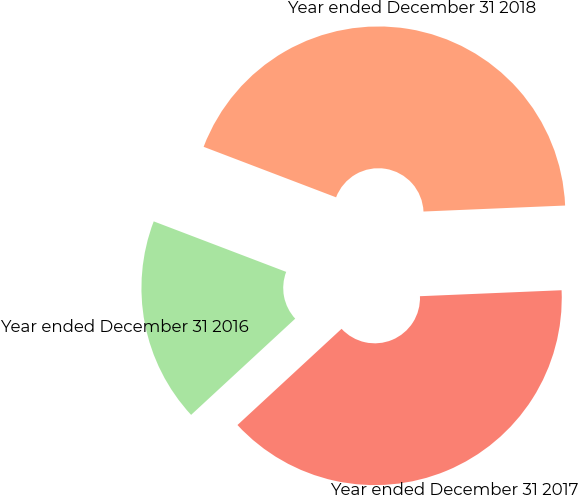Convert chart. <chart><loc_0><loc_0><loc_500><loc_500><pie_chart><fcel>Year ended December 31 2018<fcel>Year ended December 31 2017<fcel>Year ended December 31 2016<nl><fcel>43.53%<fcel>38.8%<fcel>17.67%<nl></chart> 